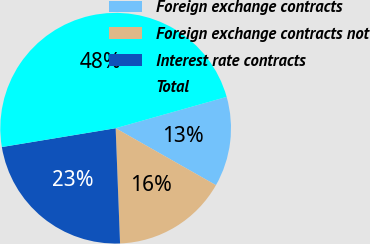<chart> <loc_0><loc_0><loc_500><loc_500><pie_chart><fcel>Foreign exchange contracts<fcel>Foreign exchange contracts not<fcel>Interest rate contracts<fcel>Total<nl><fcel>12.6%<fcel>16.17%<fcel>23.0%<fcel>48.23%<nl></chart> 